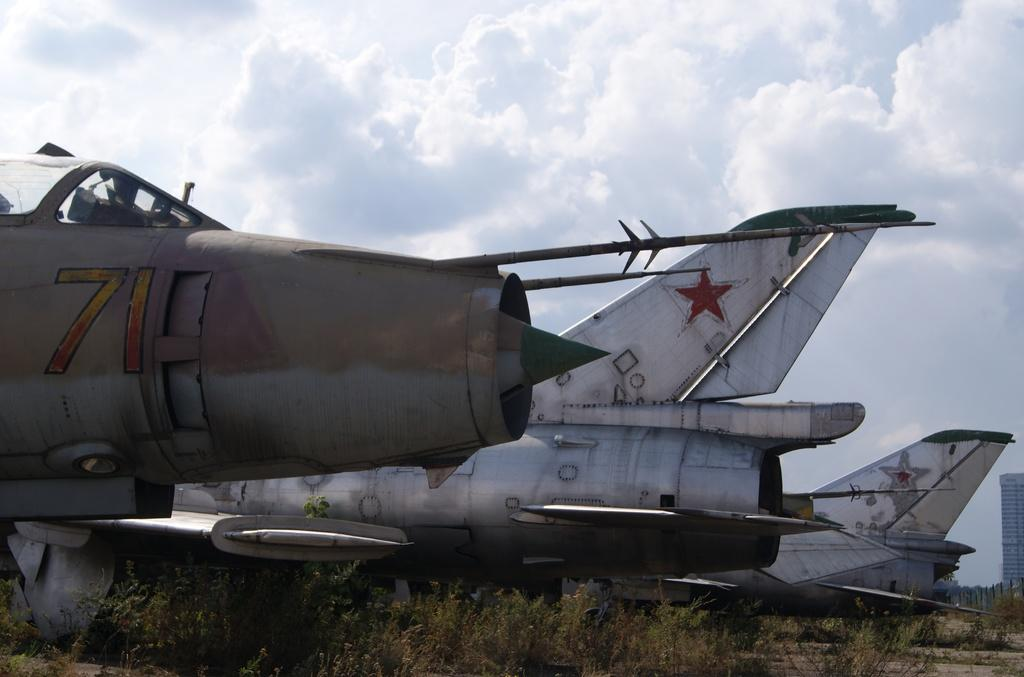<image>
Give a short and clear explanation of the subsequent image. An old airplane numbered 71 rests with two otheres in a field. 